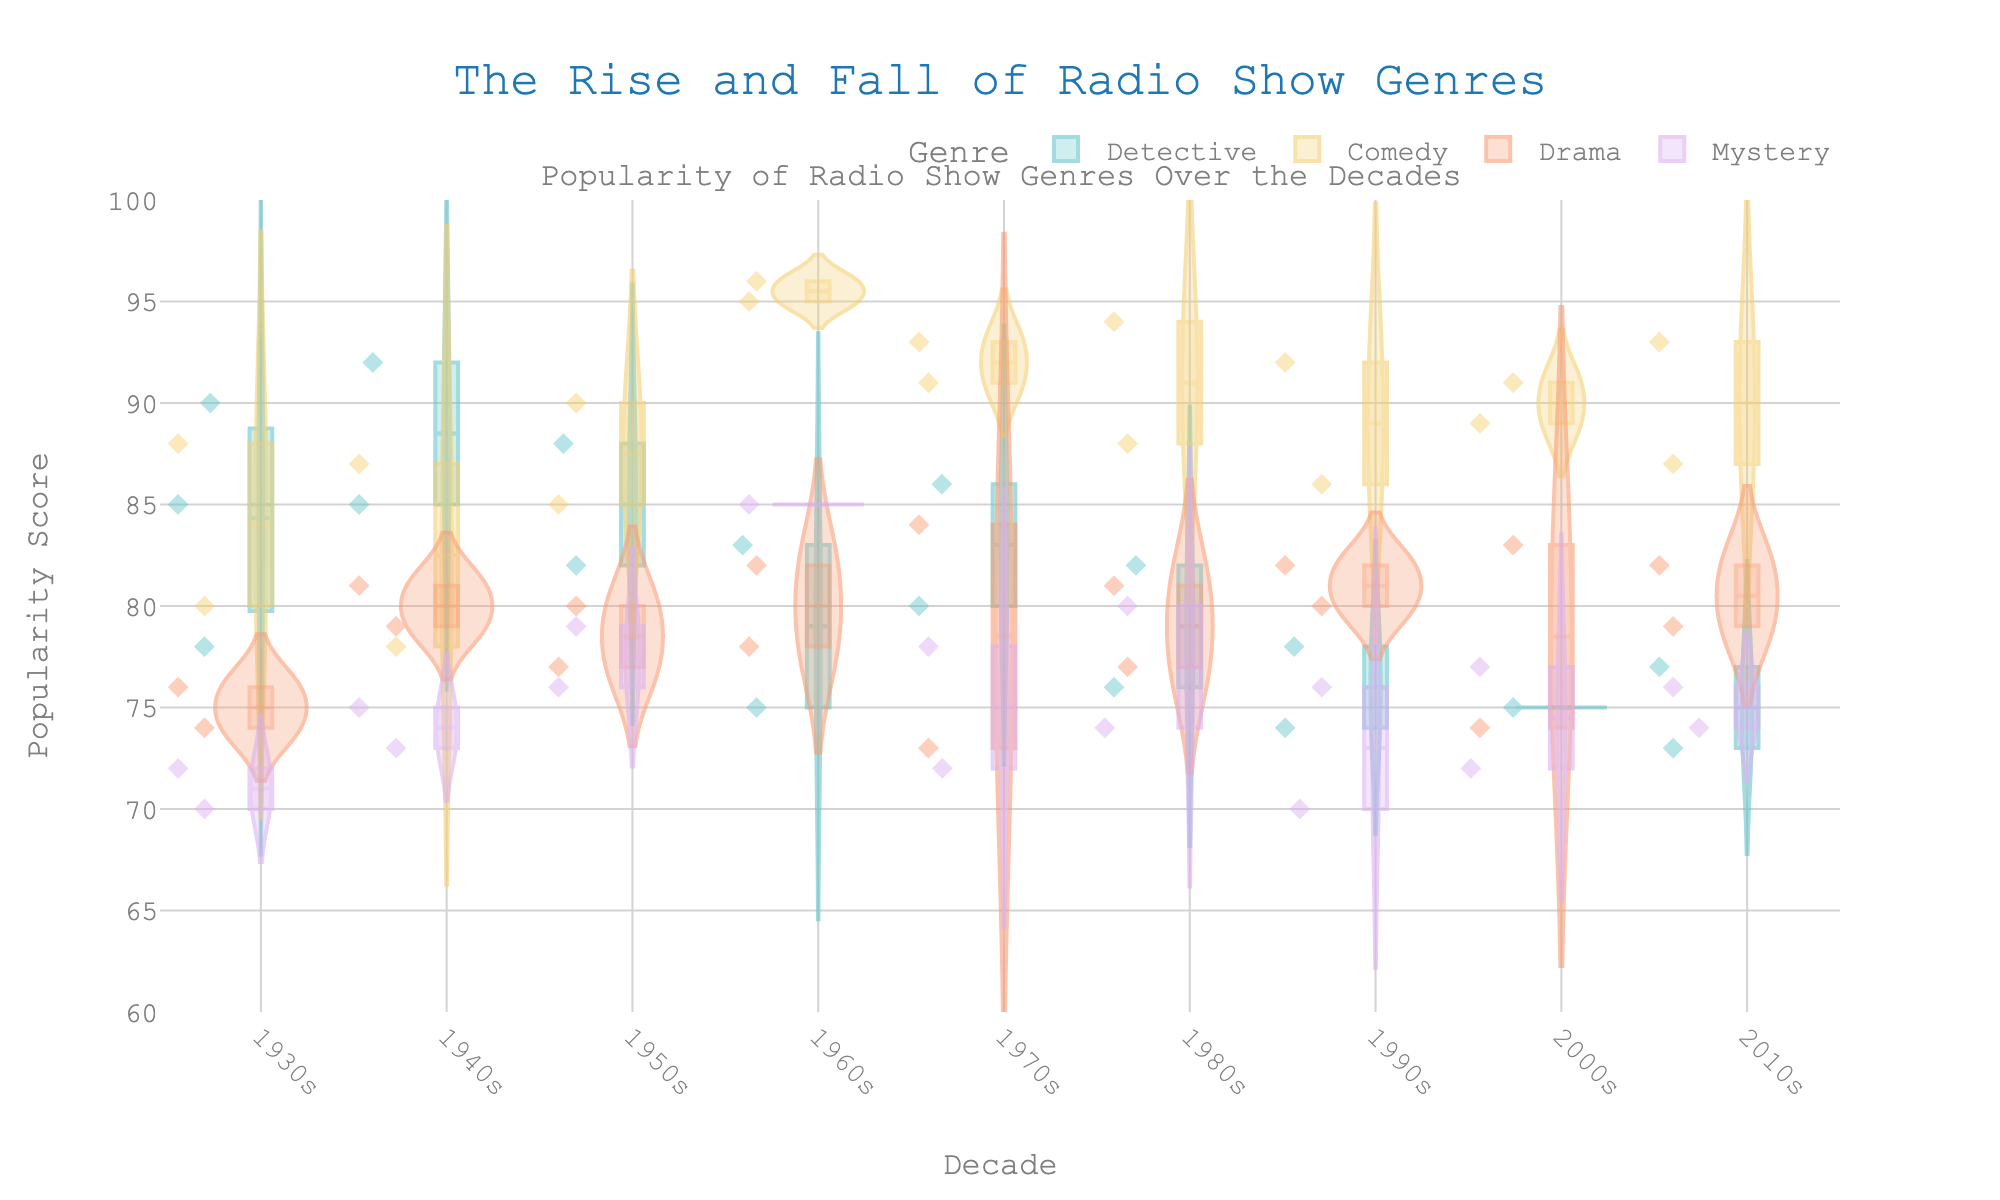What is the title of the chart? The title is located at the top center of the plot and reads "The Rise and Fall of Radio Show Genres".
Answer: The Rise and Fall of Radio Show Genres Which genre has the highest median popularity score in the 1960s? To find this, look for the violin plot segment for the 1960s and compare the median lines (indicated by the thicker line) across each genre. The Comedy genre shows the highest median line.
Answer: Comedy What is the average high end of the popularity scores for Detective shows in the 1930s? The high end of the popularity score can be observed from the top whisker of the box inside the violin plot for Detective shows in the 1930s. The values are 85, 78, and 90. Summing these up gives 253, and dividing by 3 gives approximately 84.33.
Answer: 84.33 Which genre displays the most consistent popularity scores throughout the decades? Consistency can be interpreted through the tightness of the violin plots. The Detective genre typically shows the narrowest spreads, indicating more consistent popularity scores.
Answer: Detective During which decade does Comedy genre show the highest point? Look for the highest point within the violin plot for the Comedy genre. The highest score occurs in the 1960s.
Answer: 1960s What is the range of Mystery genre's popularity scores in the 1970s? For the Mystery genre in the 1970s, identify the top and bottom points of the violin plot. The highest score is 78 and the lowest is 72. Subtracting these gives a range of 6.
Answer: 6 Which decade recorded the highest average popularity score for Drama genre, and what is the score? Observe the popularity scores within each decade for Drama. Calculate the averages for each decade. The highest average occurs in the 2010s with scores of 82 and 79, giving a mean of 80.5.
Answer: 2010s, 80.5 How does the popularity score for the Mystery genre in the 1940s compare to the 1950s? Compare the median and spread of scores in the violin plots for the two decades. The 1940s have scores centered around 75, whereas the 1950s center around 77, showing a slight increase in the following decade.
Answer: Slight increase in the 1950s In which decade do all genres have the highest combined popularity scores? Sum the median popularity scores of all genres for each decade. The total is highest in the 1960s.
Answer: 1960s In which decade does the Listener Demographics for Comedy indicate the most diverse age group? The dispersion of age points within the Comedy genre's violin plots indicates diversity. The 1960s show the widest spread of data points suggesting the most diverse age group.
Answer: 1960s 